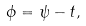Convert formula to latex. <formula><loc_0><loc_0><loc_500><loc_500>\phi = \psi - t ,</formula> 